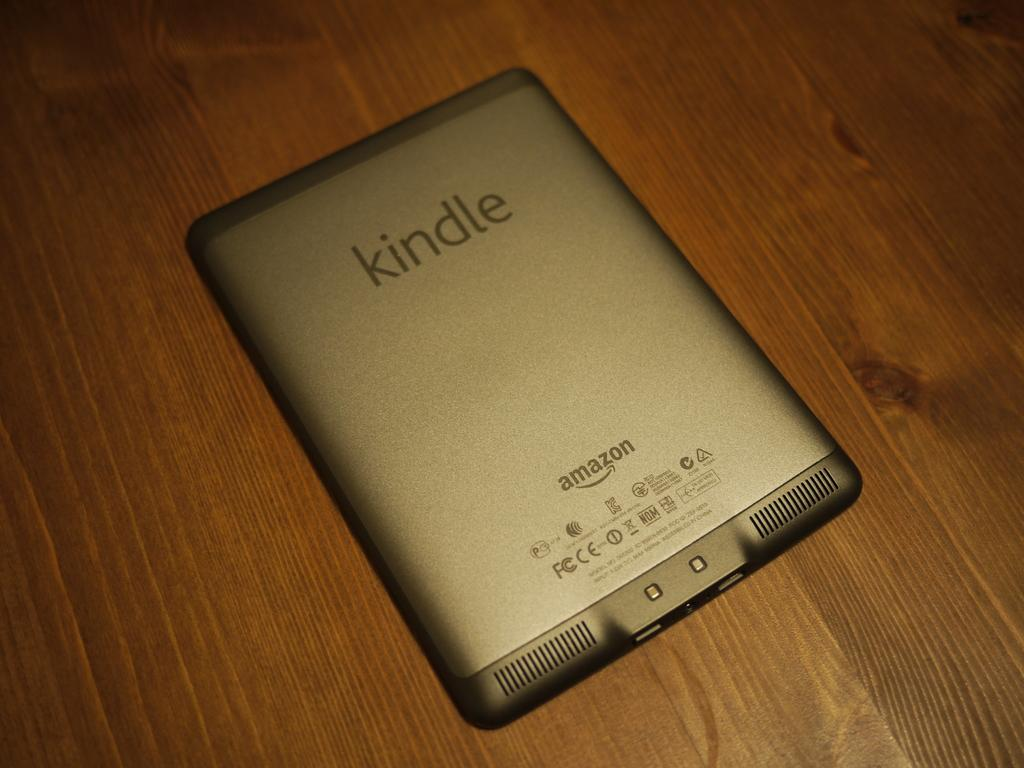<image>
Write a terse but informative summary of the picture. The silver tablet here is an Amazon Kindle 